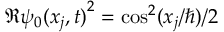Convert formula to latex. <formula><loc_0><loc_0><loc_500><loc_500>\Re { \psi _ { 0 } ( x _ { j } , t ) } ^ { 2 } = \cos ^ { 2 } ( x _ { j } / \hbar { ) } / 2</formula> 